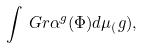<formula> <loc_0><loc_0><loc_500><loc_500>\int _ { \ } G r \alpha ^ { g } ( \Phi ) d \mu _ { ( } g ) ,</formula> 